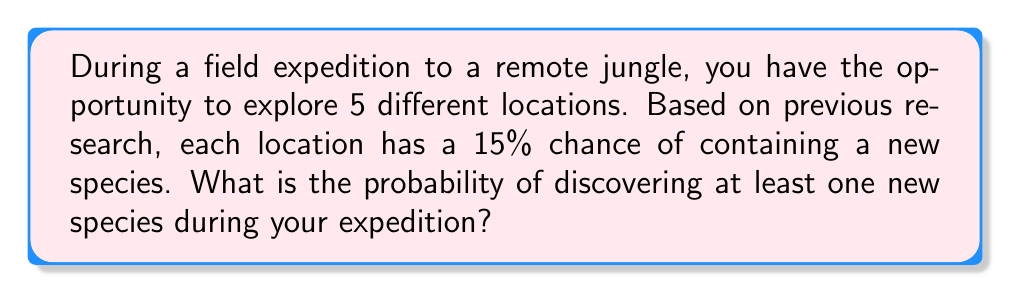Solve this math problem. Let's approach this step-by-step:

1) First, we need to calculate the probability of not finding a new species in a single location:
   $P(\text{no new species}) = 1 - 0.15 = 0.85$ or $85\%$

2) Since we're exploring 5 independent locations, we need to find the probability of not finding a new species in all 5 locations:
   $P(\text{no new species in all 5}) = 0.85^5$

3) We can calculate this:
   $0.85^5 \approx 0.4437$ or about $44.37\%$

4) Now, the probability of finding at least one new species is the opposite of finding no new species:
   $P(\text{at least one new species}) = 1 - P(\text{no new species in all 5})$

5) We can now calculate our final answer:
   $P(\text{at least one new species}) = 1 - 0.4437 = 0.5563$

Therefore, the probability of discovering at least one new species during your expedition is approximately 0.5563 or 55.63%.
Answer: $0.5563$ or $55.63\%$ 